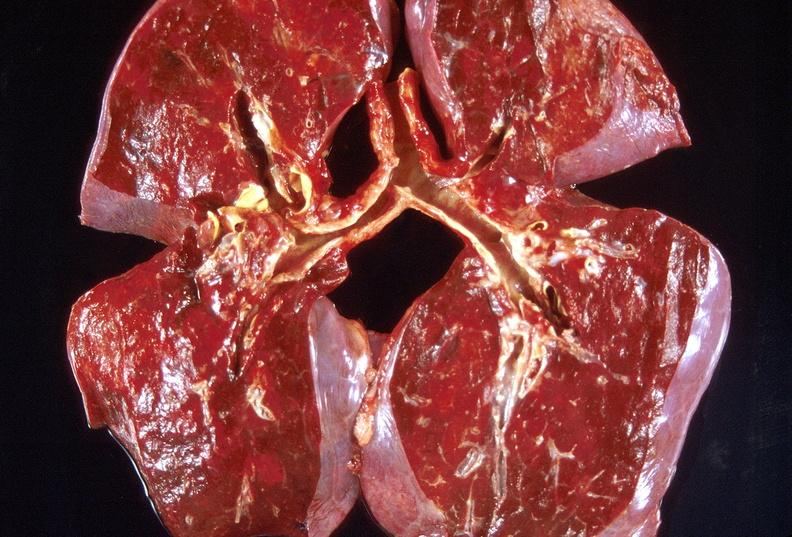s respiratory present?
Answer the question using a single word or phrase. Yes 